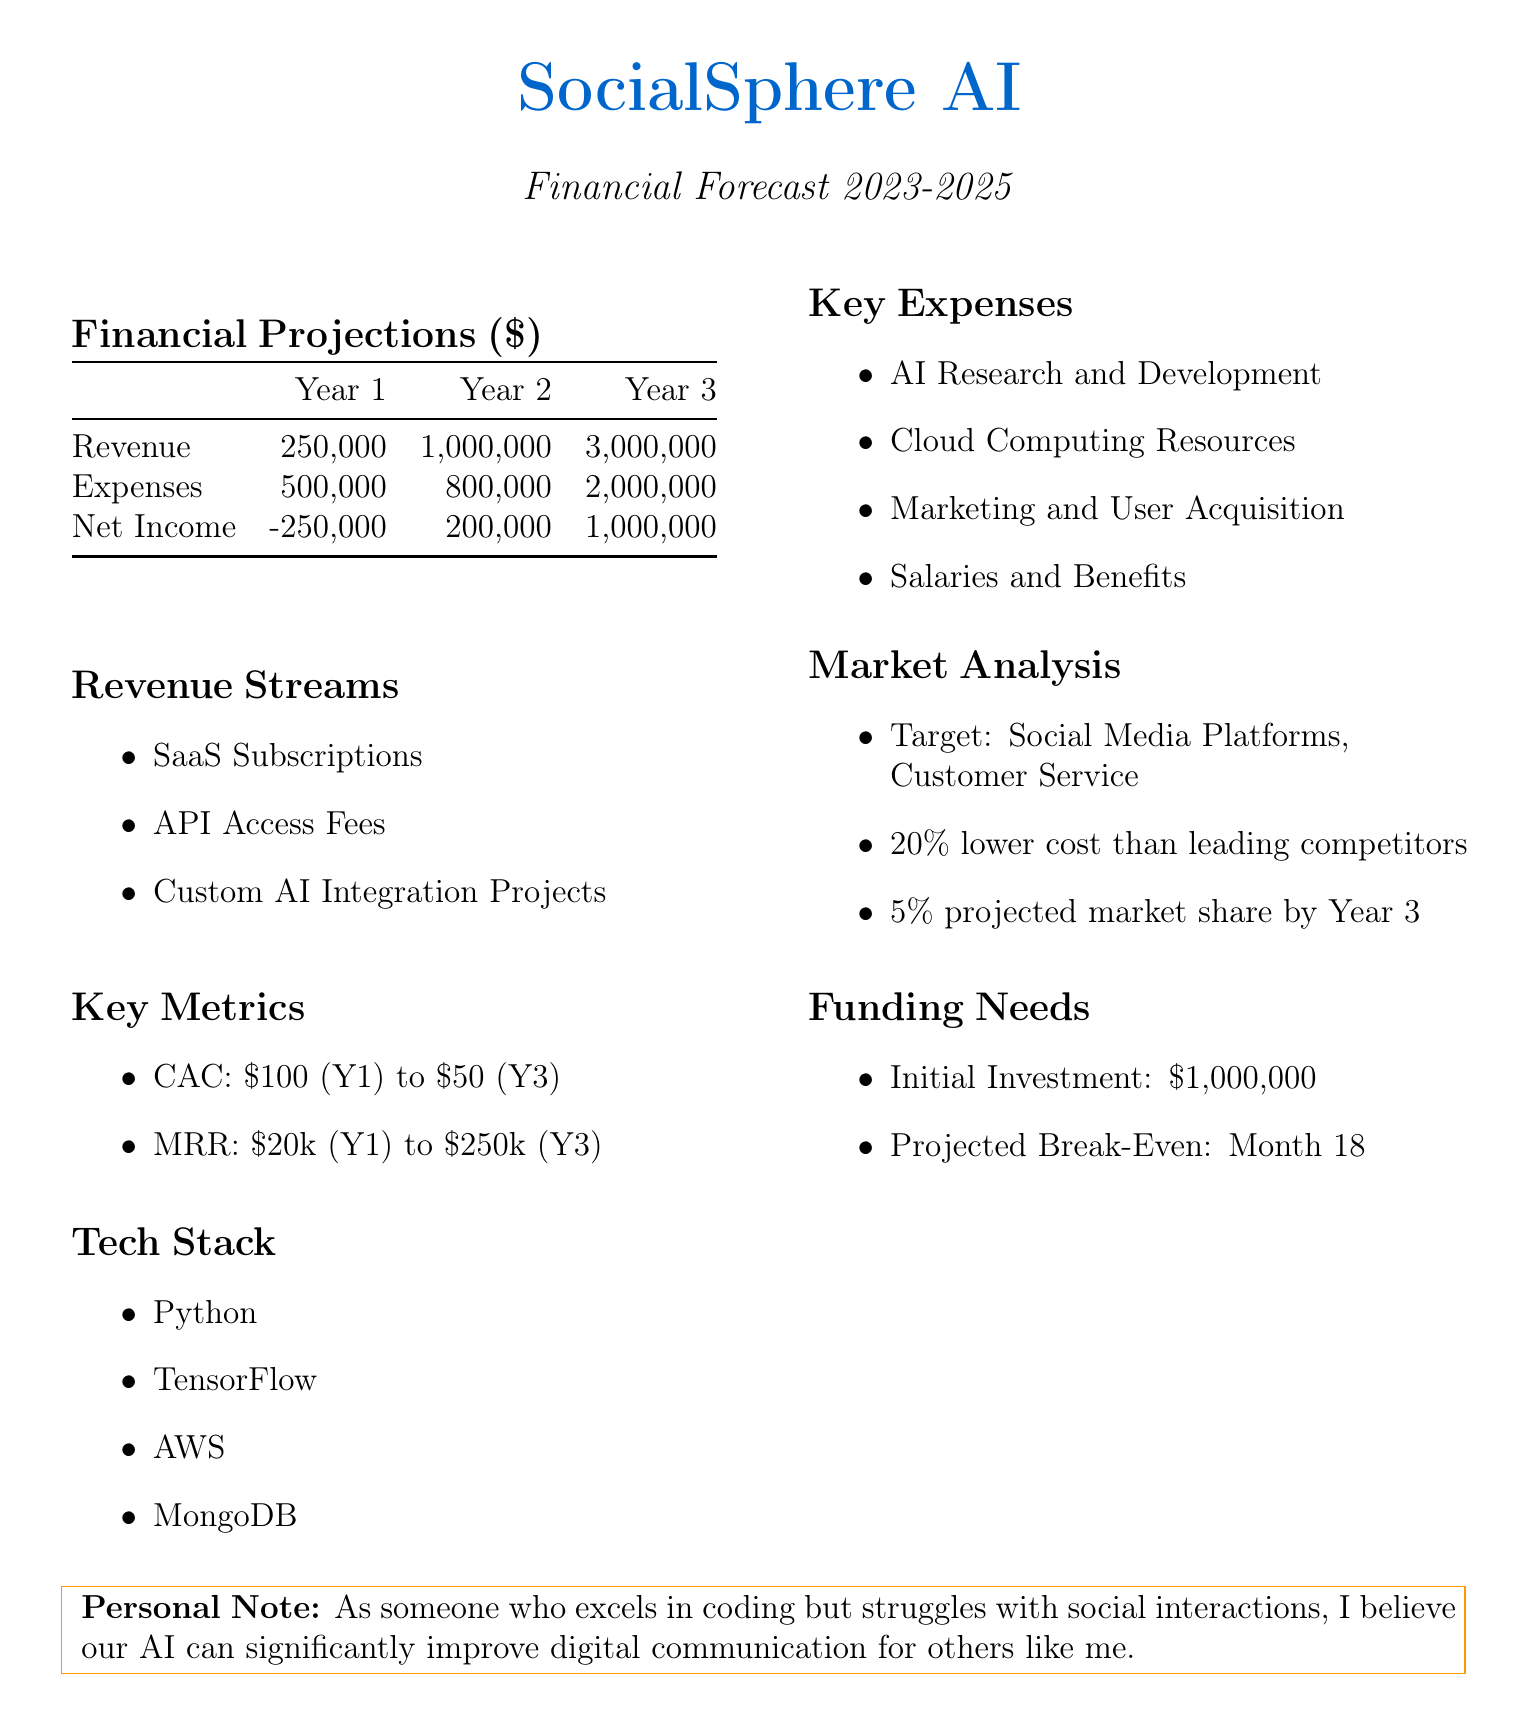What is the projected net income for Year 1? The projected net income for Year 1 is stated directly in the financial projections section of the document.
Answer: -250000 What is the total revenue forecasted for Year 3? The total revenue for Year 3 is provided in the financial projections section.
Answer: 3000000 What are the key revenue streams listed? The document outlines three key revenue streams in a dedicated section.
Answer: SaaS Subscriptions, API Access Fees, Custom AI Integration Projects What is the customer acquisition cost in Year 3? The customer acquisition cost for Year 3 is specified in the key metrics section of the document.
Answer: $50 What is the projected break-even point? The projected break-even point is mentioned under the funding needs section, indicating the timeline for achieving profitability.
Answer: Month 18 How much is the initial investment needed? The amount for initial investment is provided under the funding needs section.
Answer: $1,000,000 Which technology is mentioned as part of the tech stack? A list of technologies is referenced in the tech stack section of the document.
Answer: Python By the end of Year 3, what is the projected market share? The projected market share by the end of Year 3 is noted in the market analysis section of the document.
Answer: 5% How does the company compare in costs to competitors? The cost comparison with competitors is summarized in the market analysis section.
Answer: 20% lower cost than leading competitors 